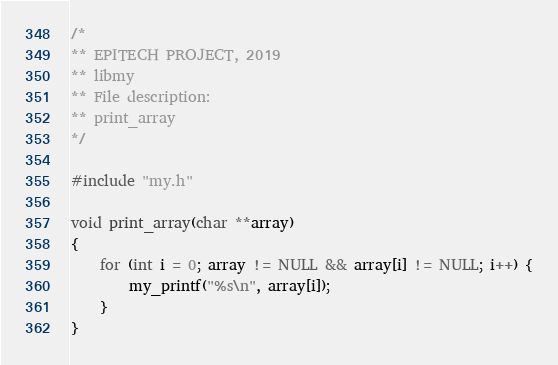<code> <loc_0><loc_0><loc_500><loc_500><_C_>/*
** EPITECH PROJECT, 2019
** libmy
** File description:
** print_array
*/

#include "my.h"

void print_array(char **array)
{
    for (int i = 0; array != NULL && array[i] != NULL; i++) {
        my_printf("%s\n", array[i]);
    }
}
</code> 